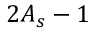Convert formula to latex. <formula><loc_0><loc_0><loc_500><loc_500>2 A _ { s } - 1</formula> 